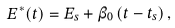<formula> <loc_0><loc_0><loc_500><loc_500>E ^ { \ast } ( t ) = E _ { s } + \beta _ { 0 } \left ( t - t _ { s } \right ) ,</formula> 